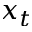Convert formula to latex. <formula><loc_0><loc_0><loc_500><loc_500>x _ { t }</formula> 